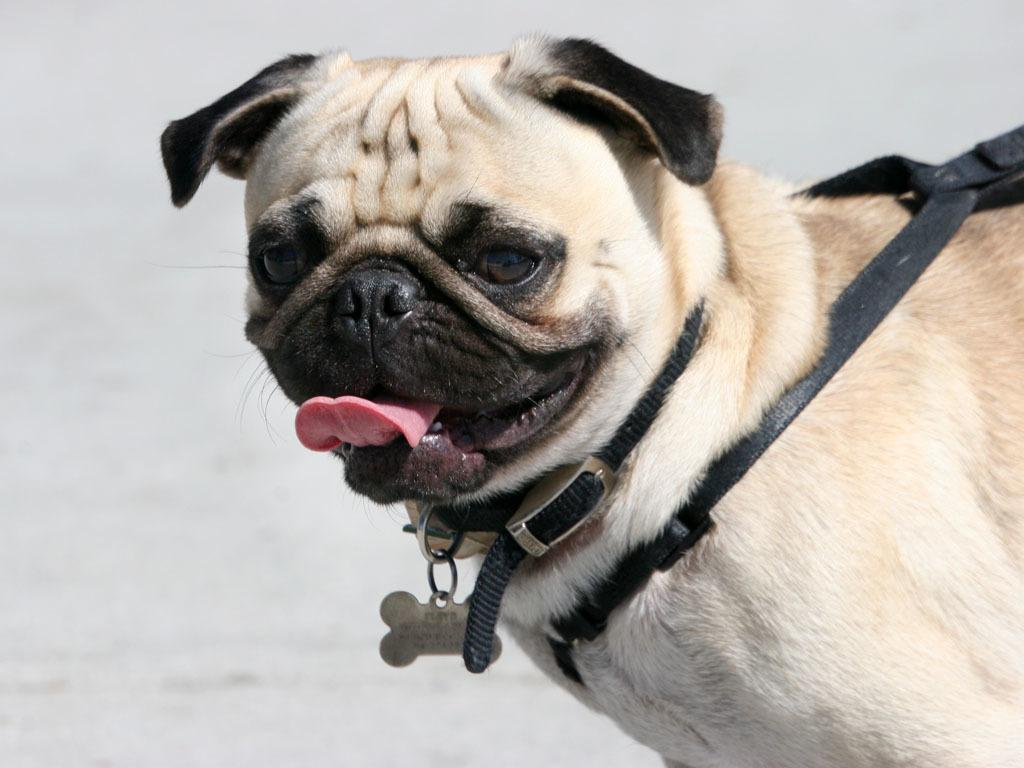What type of animal is in the image? There is a dog in the image. What color is the background of the image? The background of the image is white. What type of debt is the dog trying to pay off in the image? There is no mention of debt in the image, as it features a dog and a white background. 